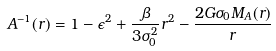<formula> <loc_0><loc_0><loc_500><loc_500>A ^ { - 1 } ( r ) = 1 - \epsilon ^ { 2 } + \frac { \beta } { 3 \sigma _ { 0 } ^ { 2 } } r ^ { 2 } - \frac { 2 G \sigma _ { 0 } M _ { A } ( r ) } { r }</formula> 